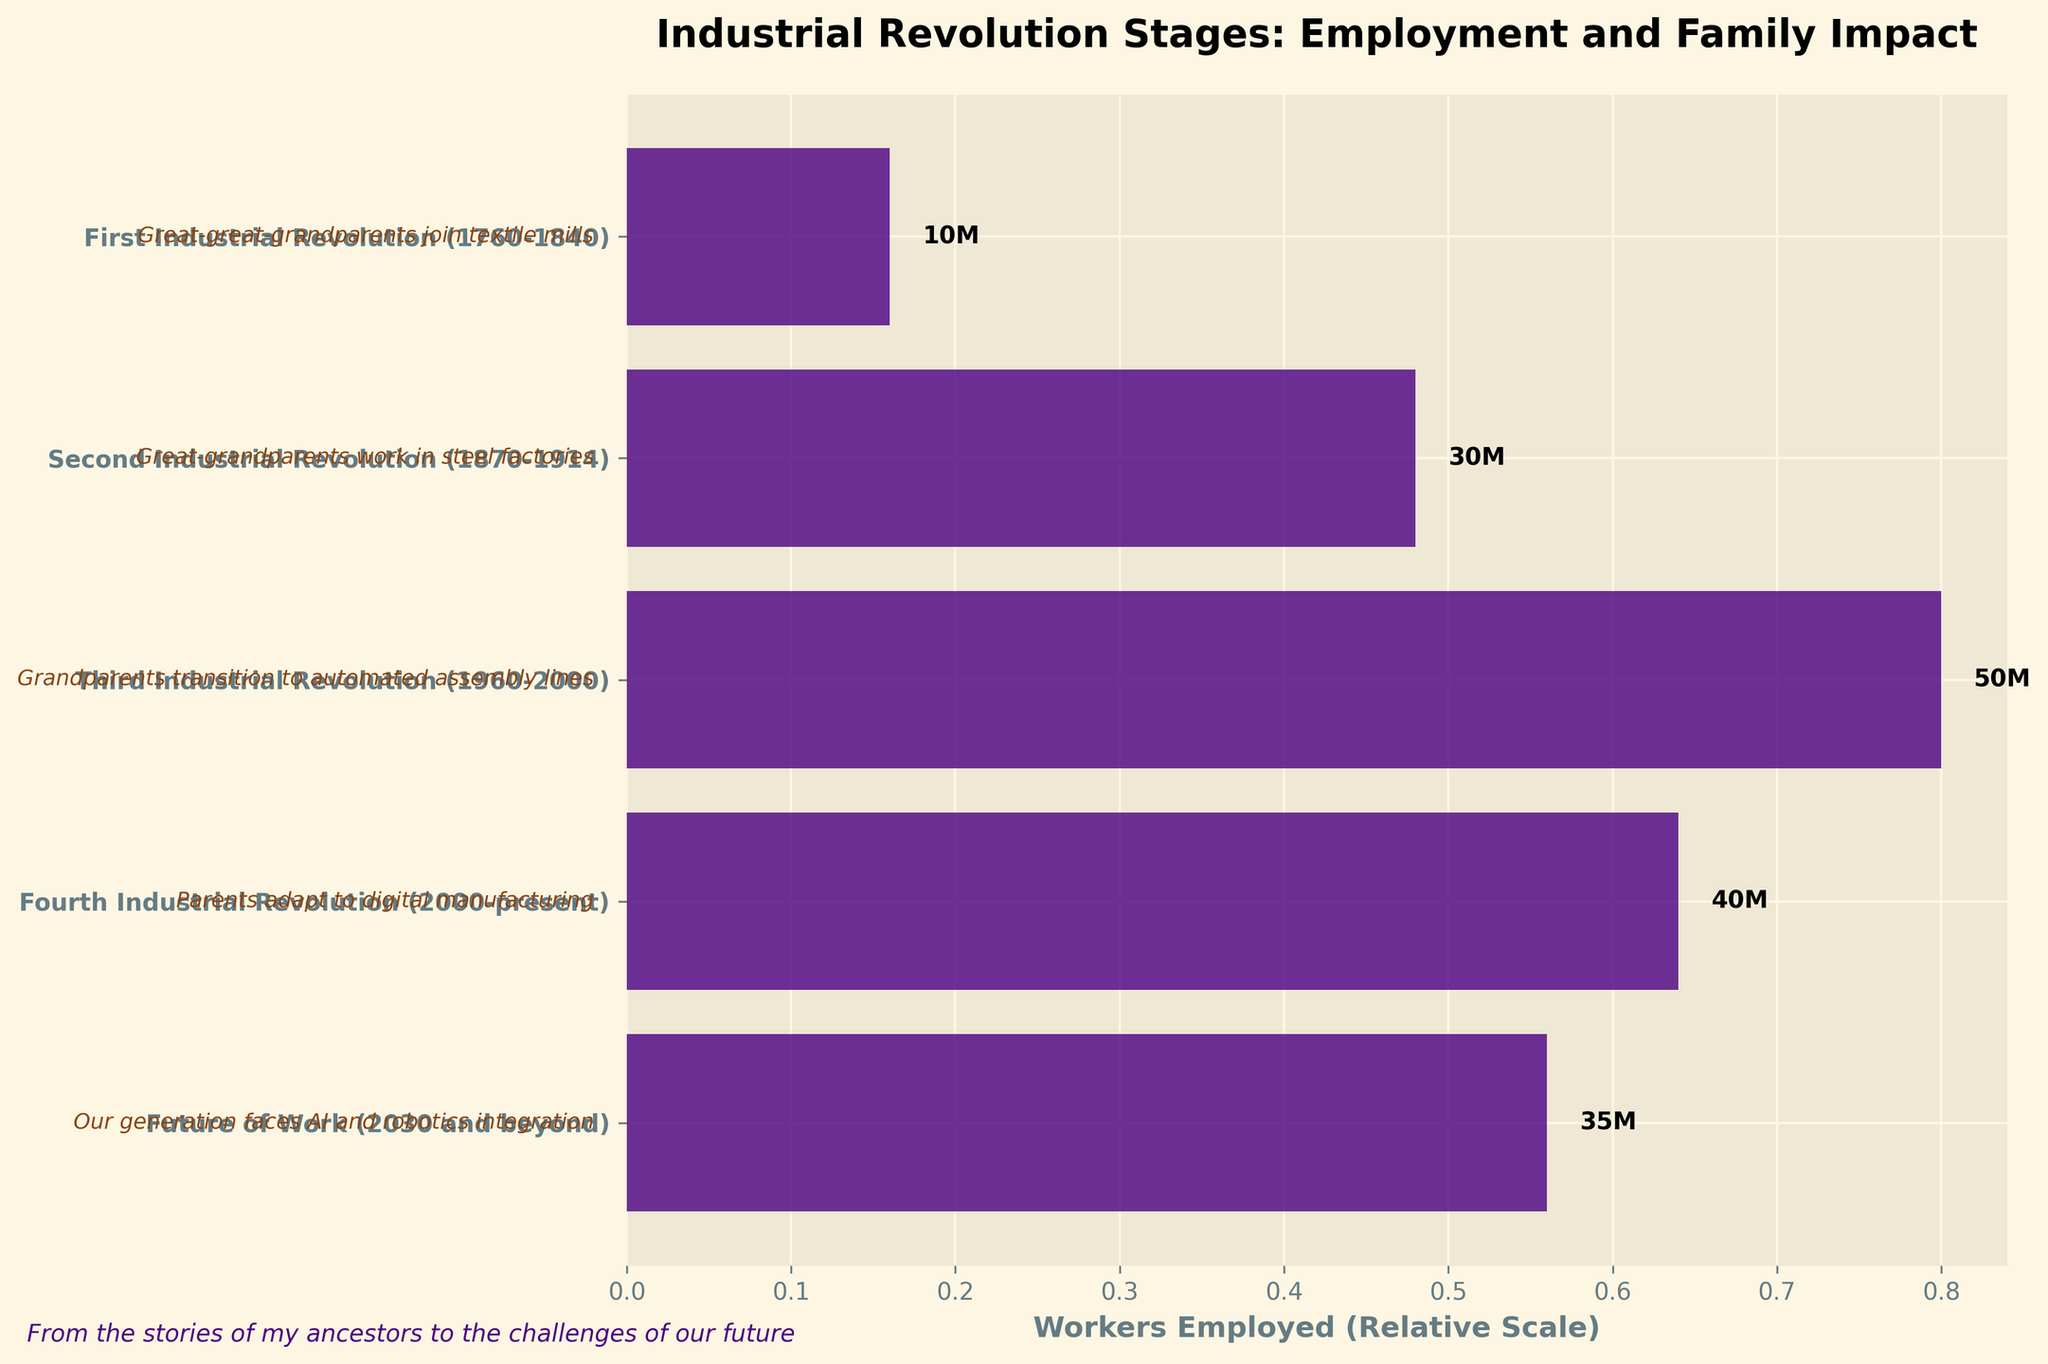What is the title of the plot? The title of the plot is written at the top of the figure.
Answer: Industrial Revolution Stages: Employment and Family Impact How many stages of the industrial revolution are shown in the plot? The number of stages can be identified by counting the number of bars or y-axis labels.
Answer: Five Which stage of the industrial revolution has the highest number of workers employed? Look for the longest bar or the highest worker count number.
Answer: Third Industrial Revolution (50 million) What is the difference in workers employed between the Third and Fourth Industrial Revolutions? Subtract the number of workers employed in the Fourth Industrial Revolution from the number in the Third.
Answer: 10 million Which stage saw grandparents transitioning to automated assembly lines according to family legacy? Look for the family legacy text associated with the stage mentioning "grandparents transition to automated assembly lines."
Answer: Third Industrial Revolution In which stage did the employment decline compared to its preceding stage? Compare the length of the bars or worker counts between consecutive stages to find the decline.
Answer: Fourth Industrial Revolution What is the sum of workers employed in the First and Second Industrial Revolutions? Add the number of workers employed in the First Industrial Revolution to the number in the Second.
Answer: 40 million Which stage has a digital manufacturing impact on family legacy? Look for the family legacy text mentioning "adapt to digital manufacturing."
Answer: Fourth Industrial Revolution How does worker employment change from the Fourth Industrial Revolution to the Future of Work? Compare the number of workers employed in the Fourth Industrial Revolution to the number in the Future of Work.
Answer: It decreases by 5 million What relationship is depicted by the y-axis of the plot? The y-axis labels indicate the different stages of the industrial revolution in chronological order.
Answer: The chronological stages of the industrial revolution 